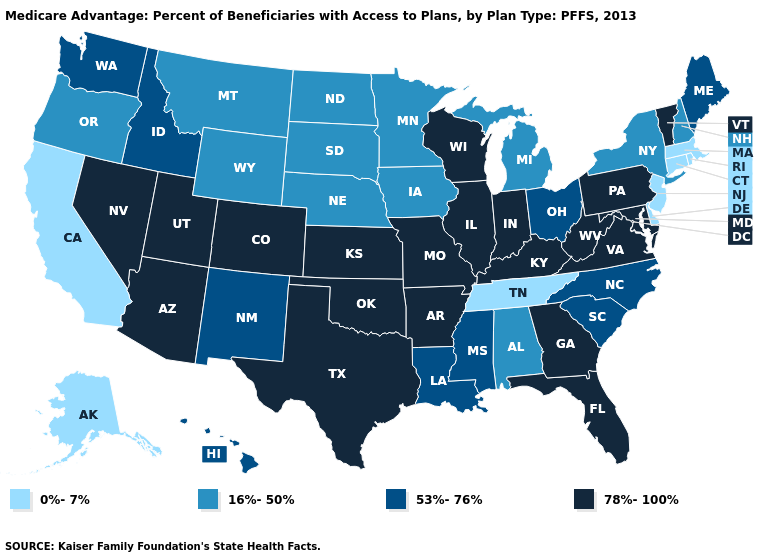Does the first symbol in the legend represent the smallest category?
Write a very short answer. Yes. Does Delaware have the lowest value in the USA?
Quick response, please. Yes. Which states have the highest value in the USA?
Answer briefly. Arkansas, Arizona, Colorado, Florida, Georgia, Illinois, Indiana, Kansas, Kentucky, Maryland, Missouri, Nevada, Oklahoma, Pennsylvania, Texas, Utah, Virginia, Vermont, Wisconsin, West Virginia. Which states hav the highest value in the West?
Be succinct. Arizona, Colorado, Nevada, Utah. Which states hav the highest value in the MidWest?
Be succinct. Illinois, Indiana, Kansas, Missouri, Wisconsin. Name the states that have a value in the range 53%-76%?
Write a very short answer. Hawaii, Idaho, Louisiana, Maine, Mississippi, North Carolina, New Mexico, Ohio, South Carolina, Washington. Name the states that have a value in the range 53%-76%?
Be succinct. Hawaii, Idaho, Louisiana, Maine, Mississippi, North Carolina, New Mexico, Ohio, South Carolina, Washington. Does Pennsylvania have the highest value in the USA?
Write a very short answer. Yes. What is the lowest value in the South?
Short answer required. 0%-7%. Among the states that border Idaho , which have the highest value?
Be succinct. Nevada, Utah. What is the highest value in the Northeast ?
Short answer required. 78%-100%. Name the states that have a value in the range 0%-7%?
Quick response, please. Alaska, California, Connecticut, Delaware, Massachusetts, New Jersey, Rhode Island, Tennessee. Name the states that have a value in the range 0%-7%?
Concise answer only. Alaska, California, Connecticut, Delaware, Massachusetts, New Jersey, Rhode Island, Tennessee. Does Rhode Island have the same value as Nebraska?
Short answer required. No. Name the states that have a value in the range 16%-50%?
Short answer required. Alabama, Iowa, Michigan, Minnesota, Montana, North Dakota, Nebraska, New Hampshire, New York, Oregon, South Dakota, Wyoming. 